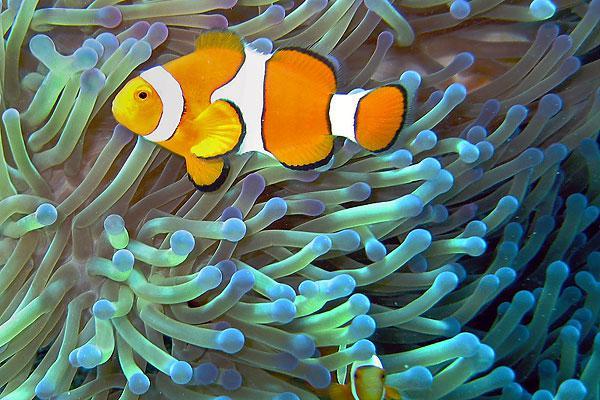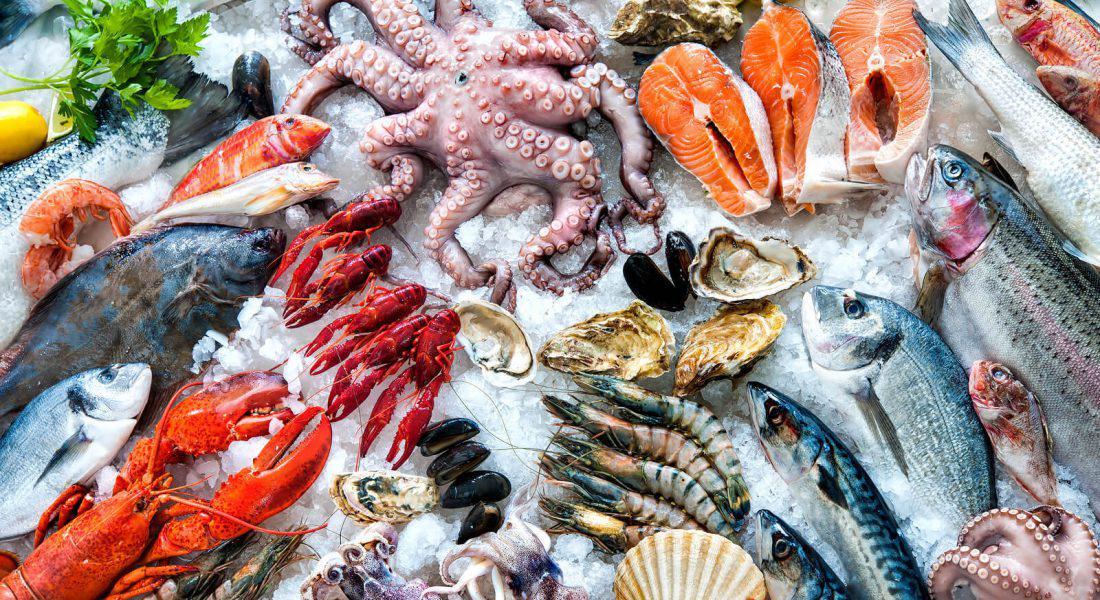The first image is the image on the left, the second image is the image on the right. Given the left and right images, does the statement "Each image features clownfish swimming in front of anemone tendrils, and no image contains more than four clownfish." hold true? Answer yes or no. No. 